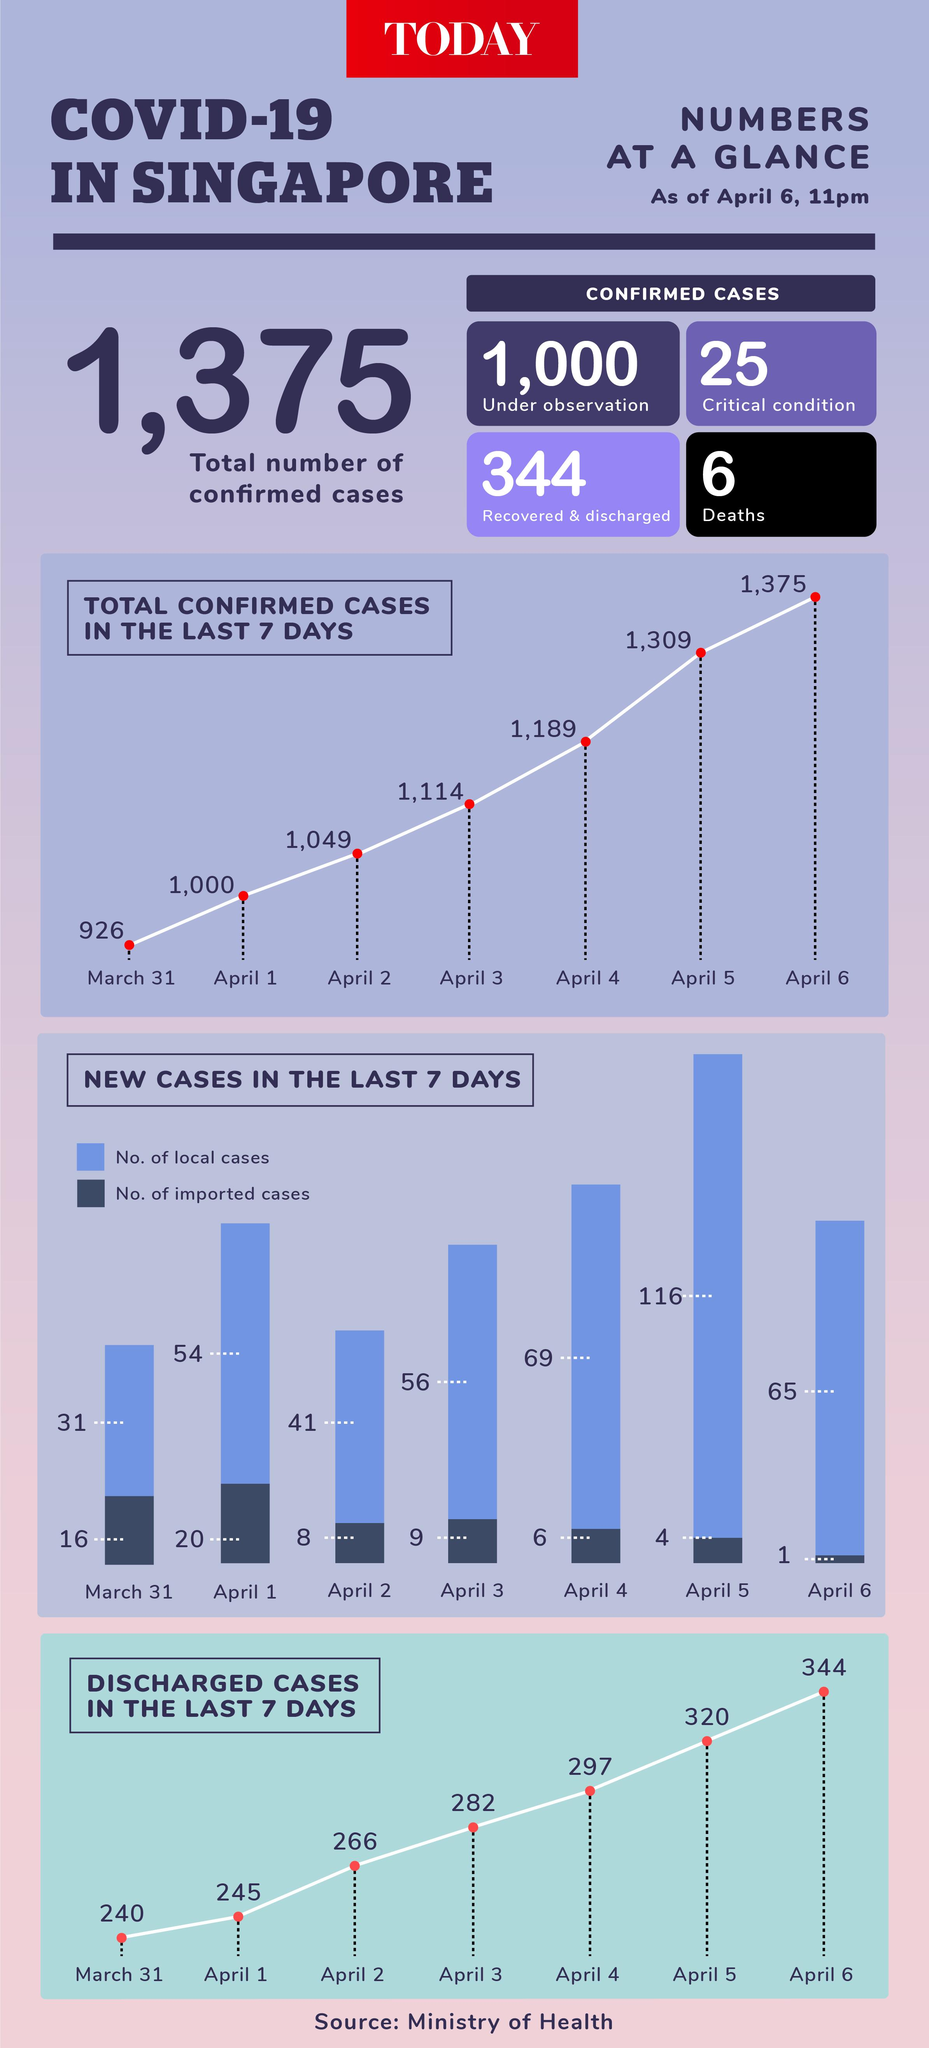Specify some key components in this picture. On April 5, a total of 116 new local cases were reported. The number of discharged cases increased by 37 from April 1 to April 3. Out of the confirmed COVID-19 cases in Singapore, it has been reported that six individuals have lost their lives. There were 9 imported cases on April 3. On April 6th, the total number of new local and imported cases was 66. 